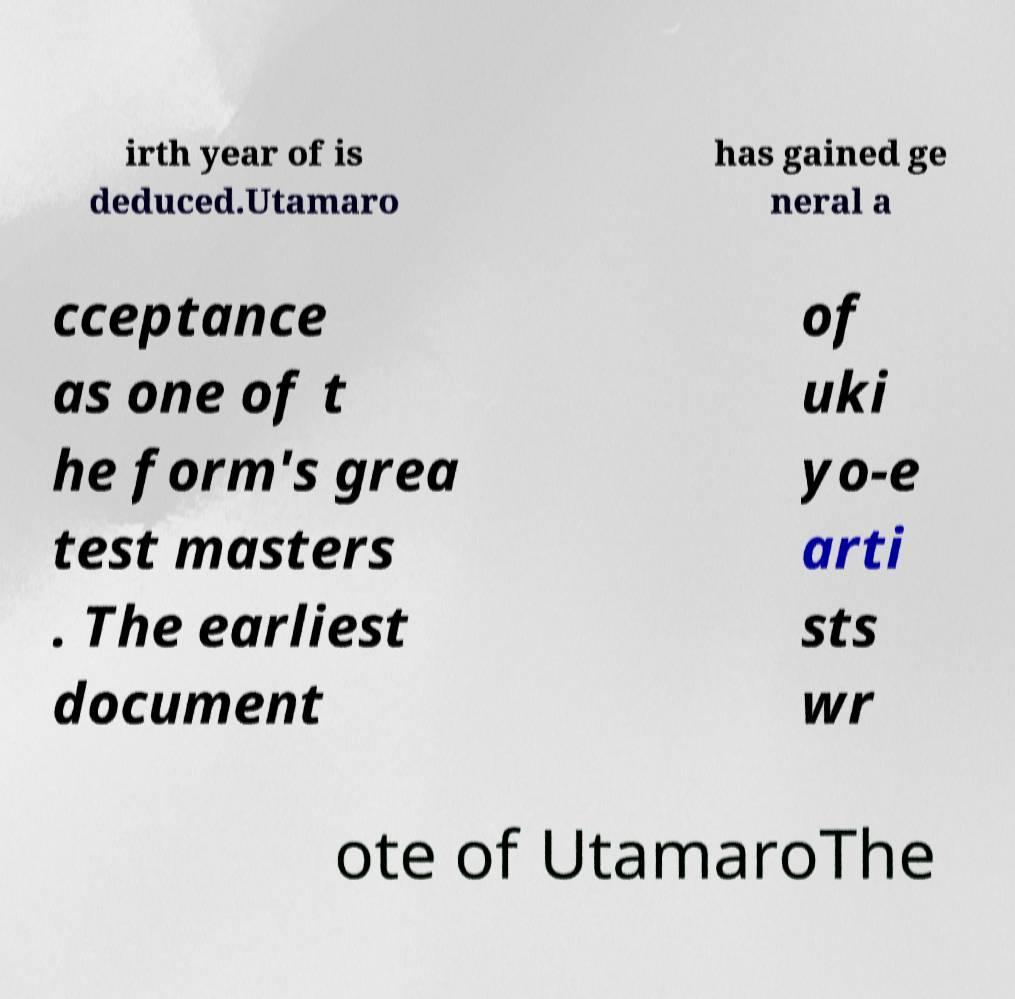Could you assist in decoding the text presented in this image and type it out clearly? irth year of is deduced.Utamaro has gained ge neral a cceptance as one of t he form's grea test masters . The earliest document of uki yo-e arti sts wr ote of UtamaroThe 